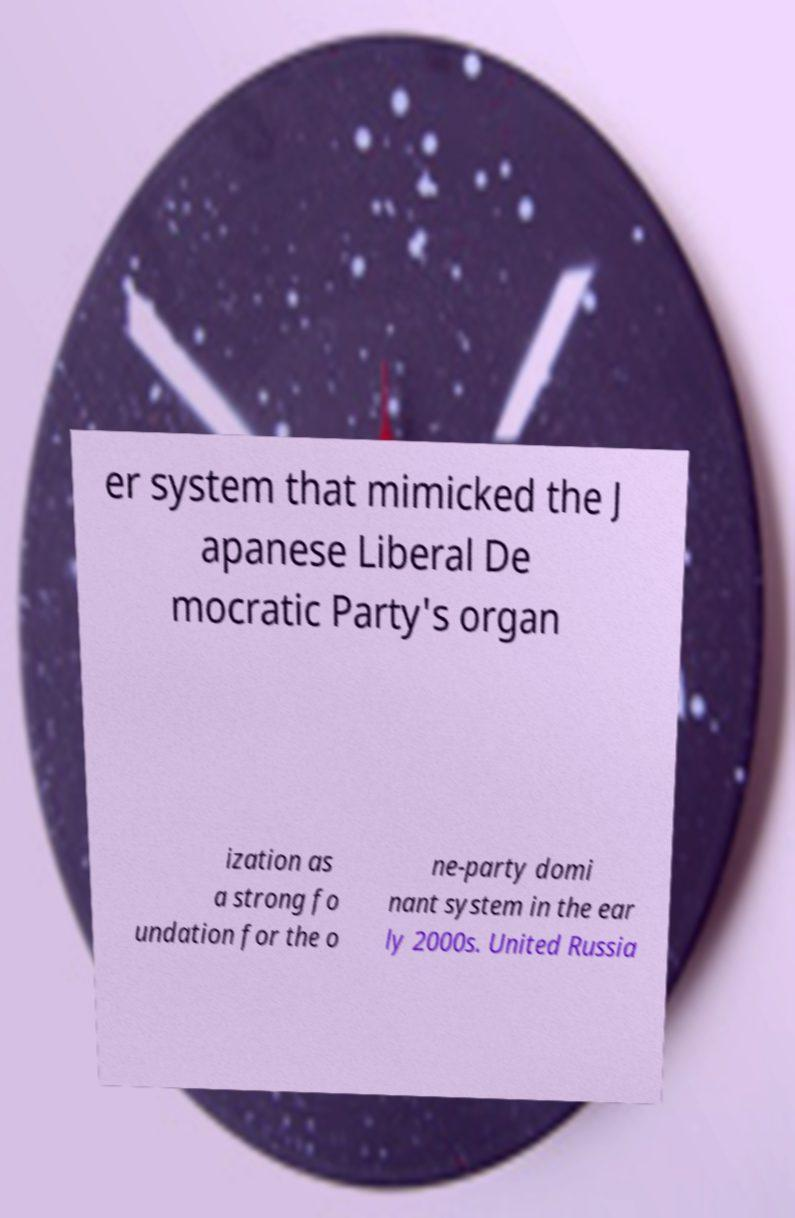Please identify and transcribe the text found in this image. er system that mimicked the J apanese Liberal De mocratic Party's organ ization as a strong fo undation for the o ne-party domi nant system in the ear ly 2000s. United Russia 